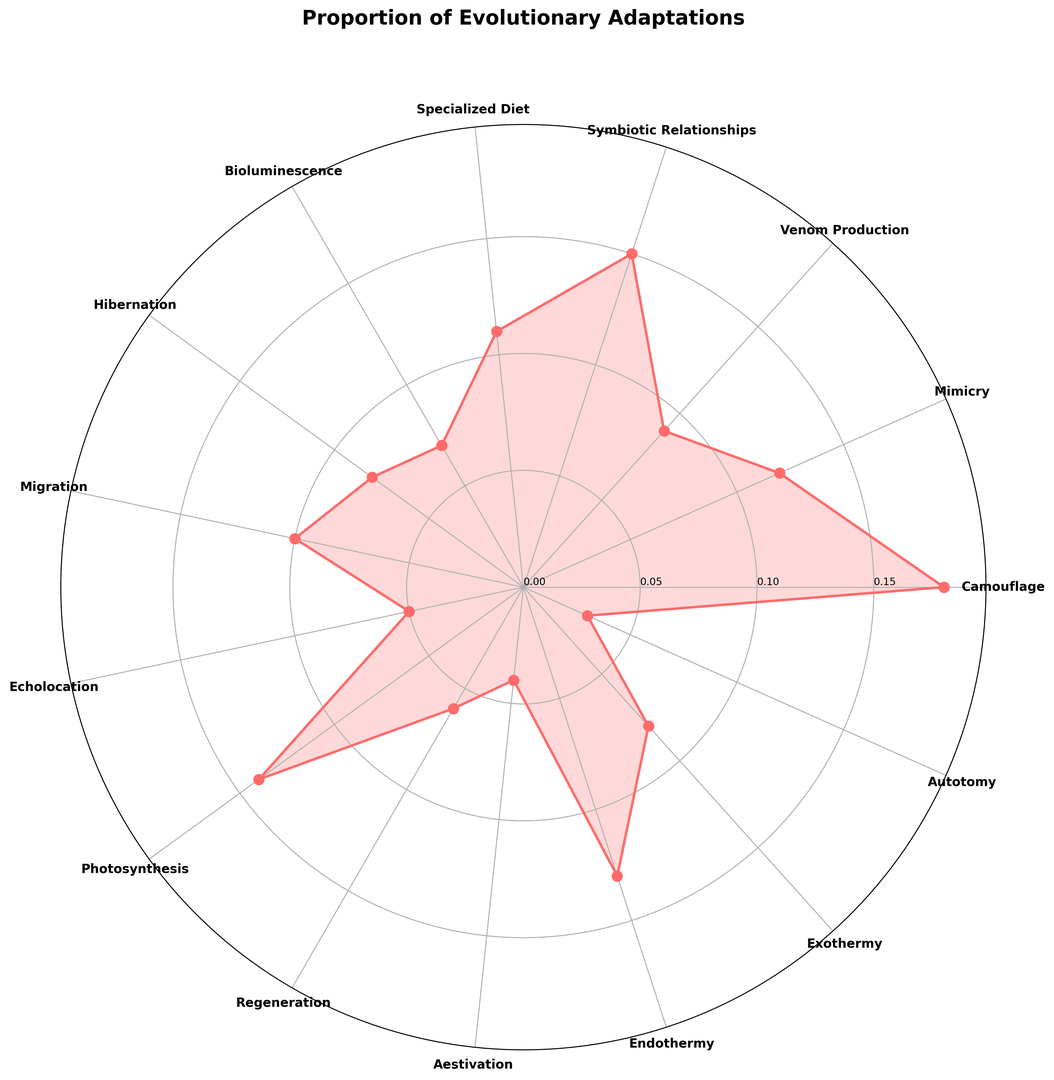Which adaptation has the highest proportion? The figure shows a radial plot with different adaptations marked around the circle. By visually scanning the plot, we can see that 'Camouflage' has the highest spike indicating the largest proportion.
Answer: Camouflage Which adaptations have a proportion greater than 0.10? By examining the radii that extend beyond the 0.10 proportion mark, we can list the adaptations. These are 'Camouflage', 'Symbiotic Relationships', 'Photosynthesis', 'Specialized Diet', and 'Endothermy'.
Answer: Camouflage, Symbiotic Relationships, Photosynthesis, Specialized Diet, Endothermy Which adaptation has the lowest proportion? By identifying the smallest spike in the radial graph, we can see that 'Autotomy' has the shortest length, indicating the lowest proportion.
Answer: Autotomy What is the sum of the proportions of 'Symbiotic Relationships' and 'Migration'? The proportion of 'Symbiotic Relationships' is 0.15 and 'Migration' is 0.10. Adding these together: 0.15 + 0.10 = 0.25.
Answer: 0.25 Are there any adaptations with the same proportion? By closely examining the radial plot, we notice that both 'Hibernation' and 'Exothermy' have proportions extending to 0.08, indicating equal proportions.
Answer: Yes, Hibernation and Exothermy Which adaptations fall between the proportions of 0.05 and 0.10? By reviewing the intervals demarcated on the radial plot, we observe that 'Venom Production', 'Hibernation', 'Exothermy', 'Migration', 'Echolocation', and 'Regeneration' fall between 0.05 and 0.10.
Answer: Venom Production, Hibernation, Exothermy, Migration, Echolocation, Regeneration Is the proportion of 'Bioluminescence' higher or lower than 'Migration'? Visually comparing the lengths of their radii in the radial plot, we see that 'Bioluminescence' has a shorter length (0.07) compared to 'Migration' (0.10), meaning it is lower.
Answer: Lower What is the difference in proportion between 'Photosynthesis' and 'Mimicry'? The proportion for 'Photosynthesis' is 0.14 and for 'Mimicry' it is 0.12. The difference is 0.14 - 0.12 = 0.02.
Answer: 0.02 What is the average proportion of 'Bioluminescence', 'Regeneration', and 'Autotomy'? Their respective proportions are 0.07, 0.06, and 0.03. The sum is 0.07 + 0.06 + 0.03 = 0.16. Dividing by the number of adaptations, 0.16 / 3 = 0.0533.
Answer: 0.0533 